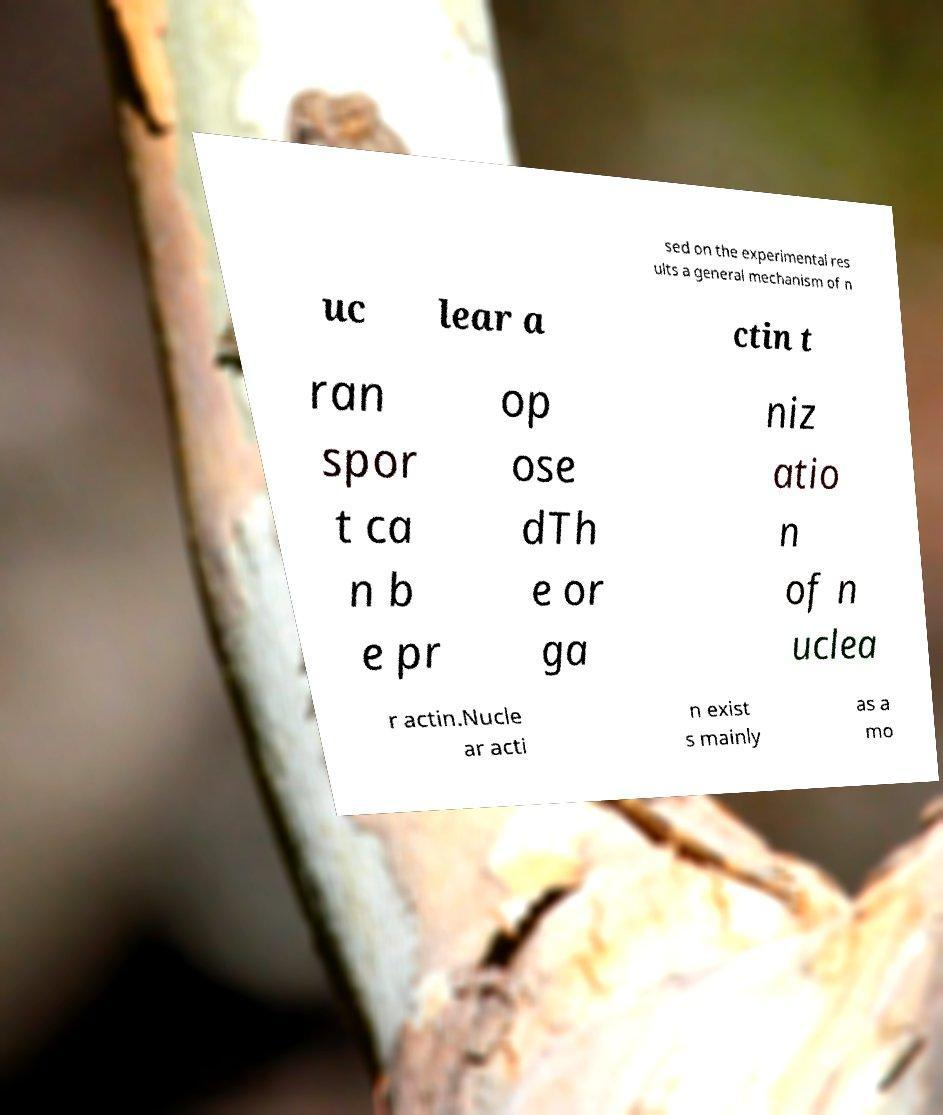There's text embedded in this image that I need extracted. Can you transcribe it verbatim? sed on the experimental res ults a general mechanism of n uc lear a ctin t ran spor t ca n b e pr op ose dTh e or ga niz atio n of n uclea r actin.Nucle ar acti n exist s mainly as a mo 